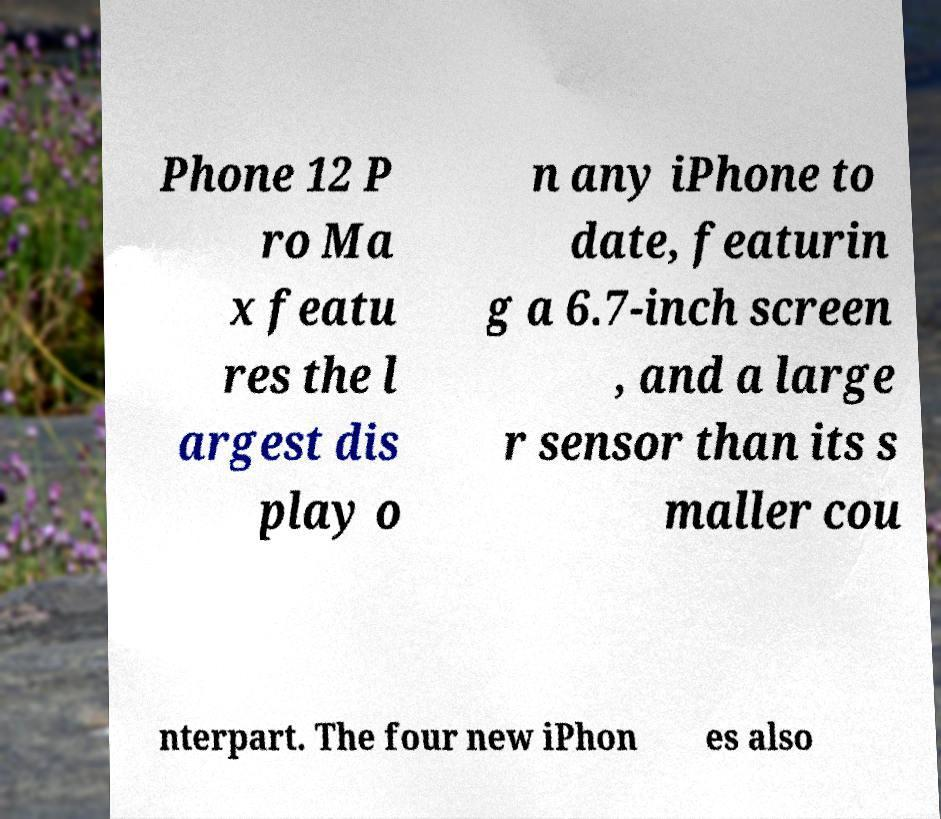For documentation purposes, I need the text within this image transcribed. Could you provide that? Phone 12 P ro Ma x featu res the l argest dis play o n any iPhone to date, featurin g a 6.7-inch screen , and a large r sensor than its s maller cou nterpart. The four new iPhon es also 